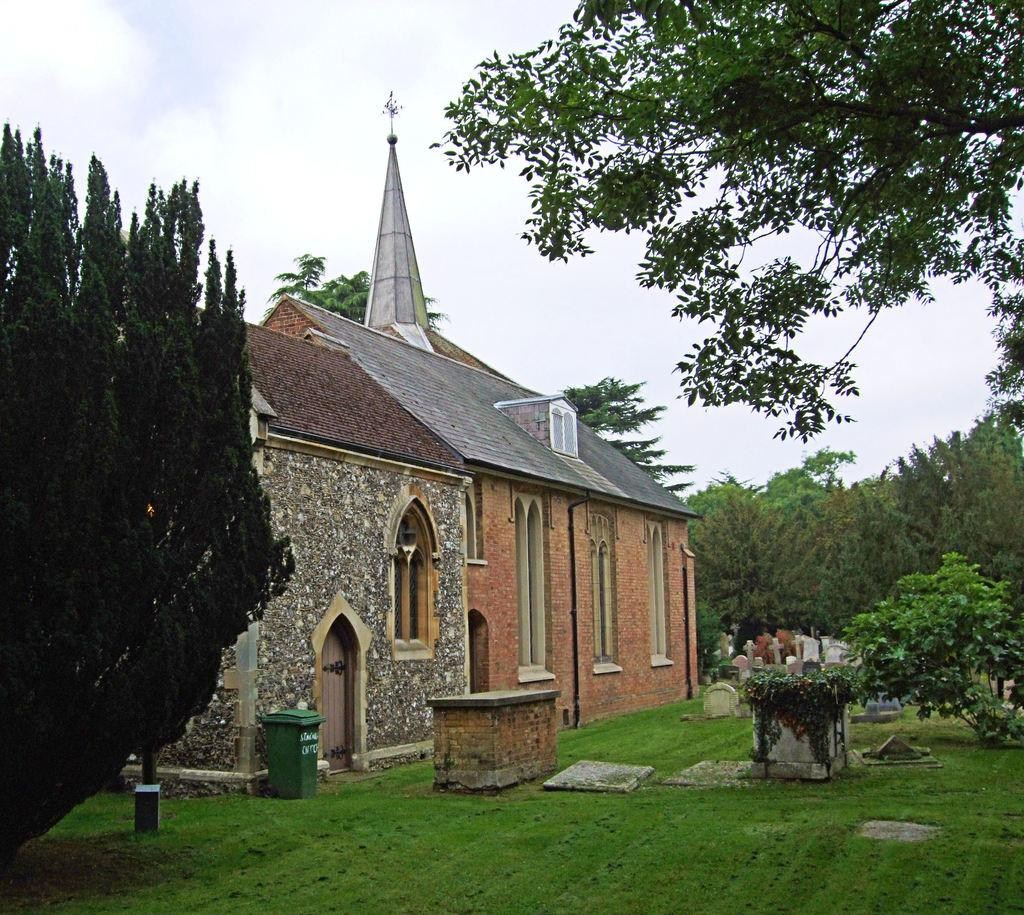What type of vegetation can be seen on the left side of the image? There are trees on the left side of the image. What type of vegetation can be seen on the right side of the image? There are trees on the right side of the image. What structures can be seen in the background of the image? There are houses in the background of the image. What architectural features can be seen in the background of the image? There are windows visible in the background of the image. What object can be seen in the background of the image? There is a dustbin in the background of the image. What type of ground cover can be seen in the background of the image? There is grass in the background of the image. What other type of vegetation can be seen in the background of the image? There are plants in the background of the image. What type of area is depicted in the background of the image? There is a graveyard in the background of the image. What can be seen in the sky in the background of the image? There are clouds in the sky in the background of the image. What type of skirt is being worn by the trees in the image? There are no skirts present in the image, as the trees are not wearing clothing. What rhythm can be heard coming from the graveyard in the image? There is no sound or rhythm mentioned in the image, so it cannot be determined from the image. 